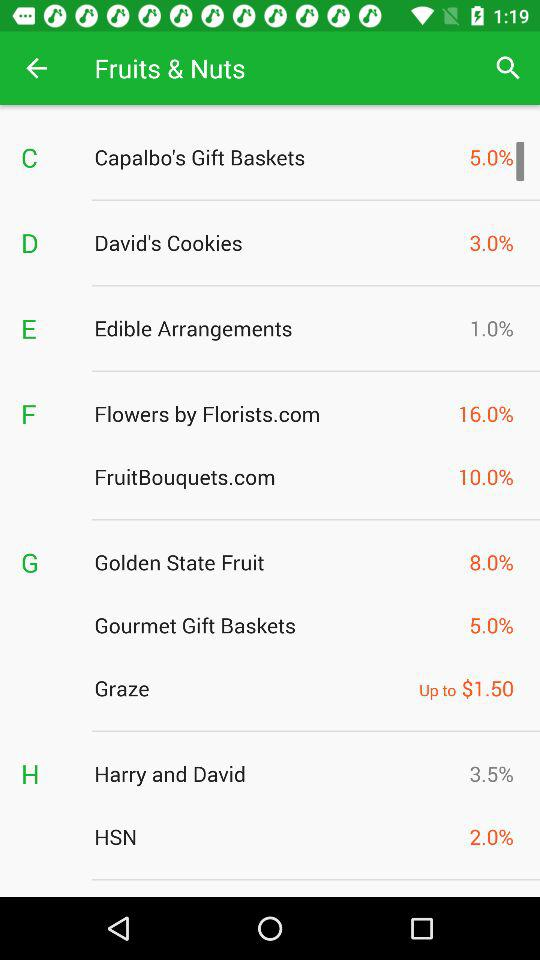How much of the "Graze" price is mentioned? The price mentioned is up to $1.50. 